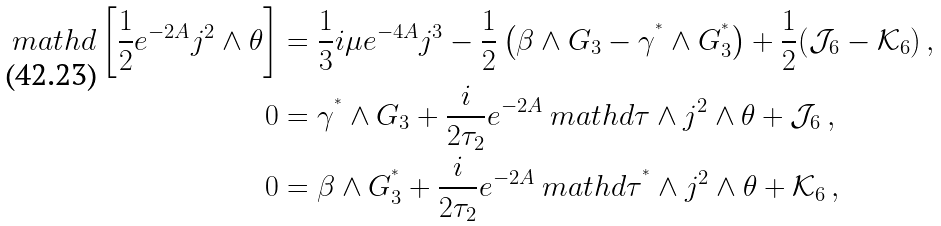<formula> <loc_0><loc_0><loc_500><loc_500>\ m a t h d \left [ \frac { 1 } { 2 } e ^ { - 2 A } j ^ { 2 } \wedge \theta \right ] & = \frac { 1 } { 3 } i \mu e ^ { - 4 A } j ^ { 3 } - \frac { 1 } { 2 } \left ( \beta \wedge G _ { 3 } - \gamma ^ { ^ { * } } \wedge G _ { 3 } ^ { ^ { * } } \right ) + \frac { 1 } { 2 } ( \mathcal { J } _ { 6 } - \mathcal { K } _ { 6 } ) \, , \\ 0 & = \gamma ^ { ^ { * } } \wedge G _ { 3 } + \frac { i } { 2 \tau _ { 2 } } e ^ { - 2 A } \ m a t h d \tau \wedge j ^ { 2 } \wedge \theta + \mathcal { J } _ { 6 } \, , \\ 0 & = \beta \wedge G _ { 3 } ^ { ^ { * } } + \frac { i } { 2 \tau _ { 2 } } e ^ { - 2 A } \ m a t h d \tau ^ { ^ { * } } \wedge j ^ { 2 } \wedge \theta + \mathcal { K } _ { 6 } \, ,</formula> 